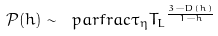<formula> <loc_0><loc_0><loc_500><loc_500>\mathcal { P } ( h ) \sim \ p a r f r a c { \tau _ { \eta } } { T _ { L } } ^ { \frac { 3 - D ( h ) } { 1 - h } }</formula> 